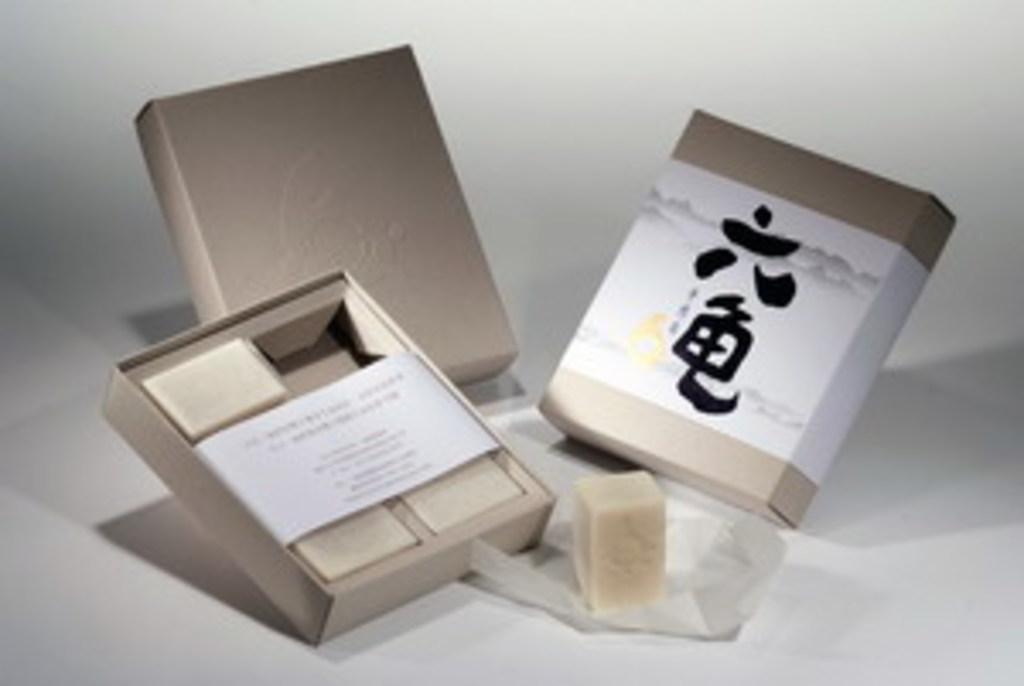How many boxes are visible in the image? There are three boxes in the image. What is placed on a surface in the image? There is an object placed on a surface in the image. What color is the background of the image? The background of the image is white in color. Can you tell me how many grapes are in the image? There are no grapes present in the image. What type of approval is being given by the boxes in the image? There is no indication of approval in the image, as it features boxes and an object on a surface with a white background. 